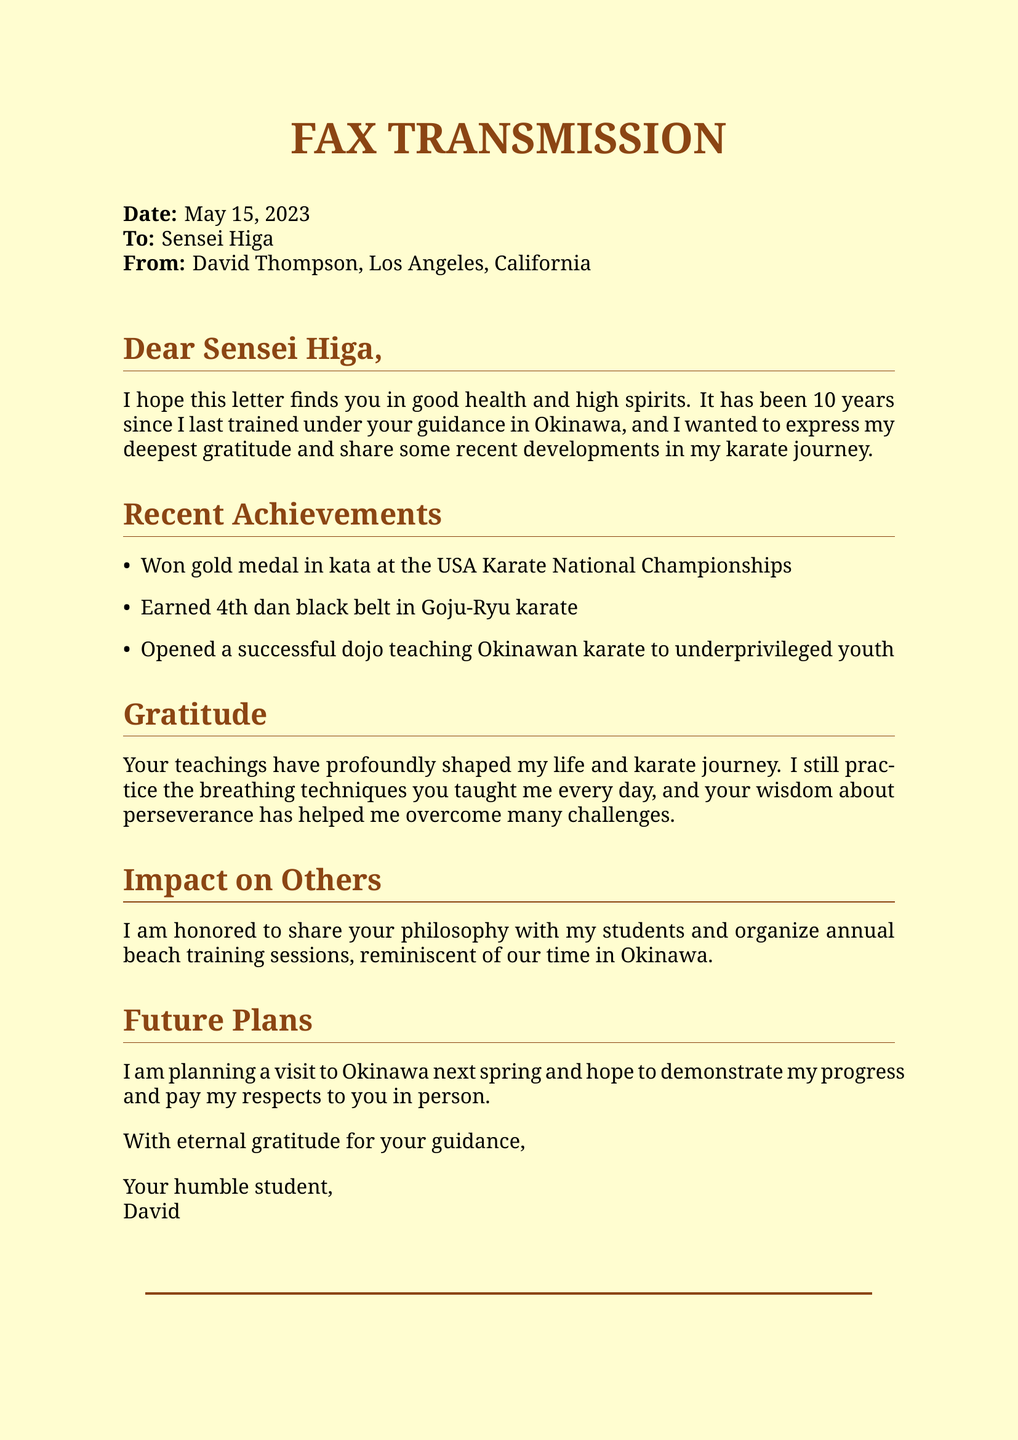what is the date of the fax? The date is indicated at the top of the document in the "Date" line.
Answer: May 15, 2023 who is the sender of the fax? The sender's name is listed under the "From" line.
Answer: David Thompson what medal did David win at the USA Karate National Championships? The document states the type of medal he won in the "Recent Achievements" section.
Answer: gold medal what rank did David achieve in Goju-Ryu karate? The rank achieved is mentioned in the "Recent Achievements" section of the fax.
Answer: 4th dan black belt how long has it been since David last trained under Sensei Higa? The duration is explicitly stated in the opening paragraph of the letter.
Answer: 10 years what is one of David's future plans mentioned in the fax? The "Future Plans" section outlines his intention regarding a visit.
Answer: visit to Okinawa what concept from Sensei Higa's teachings does David still practice daily? This is mentioned in the "Gratitude" section regarding his daily practice.
Answer: breathing techniques how does David share Sensei Higa's philosophy with his students? The method is described in the "Impact on Others" section.
Answer: organize annual beach training sessions 